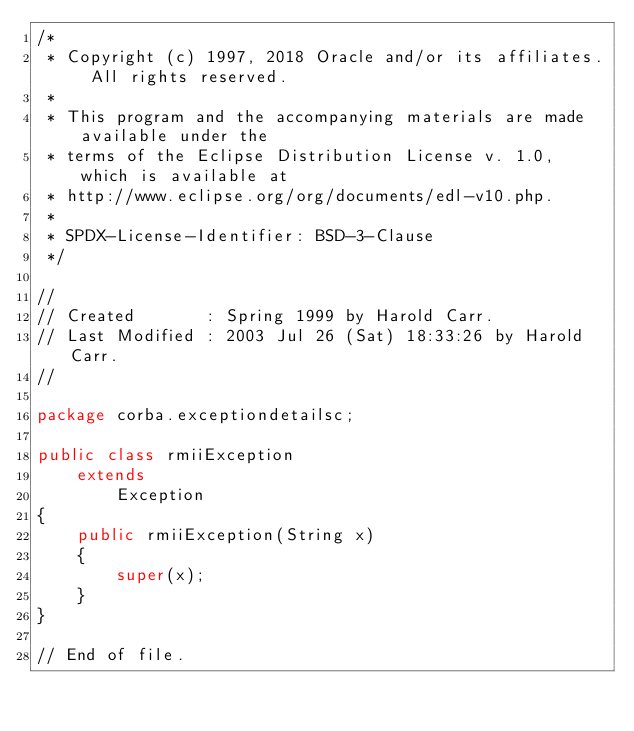Convert code to text. <code><loc_0><loc_0><loc_500><loc_500><_Java_>/*
 * Copyright (c) 1997, 2018 Oracle and/or its affiliates. All rights reserved.
 *
 * This program and the accompanying materials are made available under the
 * terms of the Eclipse Distribution License v. 1.0, which is available at
 * http://www.eclipse.org/org/documents/edl-v10.php.
 *
 * SPDX-License-Identifier: BSD-3-Clause
 */

//
// Created       : Spring 1999 by Harold Carr.
// Last Modified : 2003 Jul 26 (Sat) 18:33:26 by Harold Carr.
//

package corba.exceptiondetailsc;

public class rmiiException
    extends
        Exception
{
    public rmiiException(String x)
    {
        super(x);
    }
}

// End of file.

</code> 